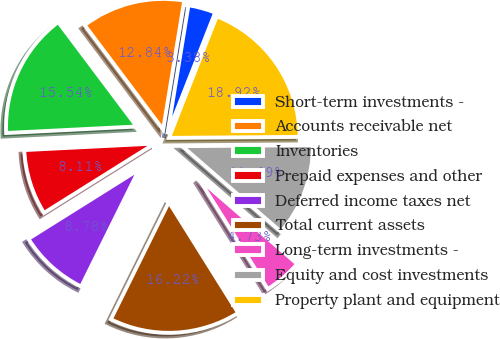Convert chart to OTSL. <chart><loc_0><loc_0><loc_500><loc_500><pie_chart><fcel>Short-term investments -<fcel>Accounts receivable net<fcel>Inventories<fcel>Prepaid expenses and other<fcel>Deferred income taxes net<fcel>Total current assets<fcel>Long-term investments -<fcel>Equity and cost investments<fcel>Property plant and equipment<nl><fcel>3.38%<fcel>12.84%<fcel>15.54%<fcel>8.11%<fcel>8.78%<fcel>16.22%<fcel>4.73%<fcel>11.49%<fcel>18.92%<nl></chart> 